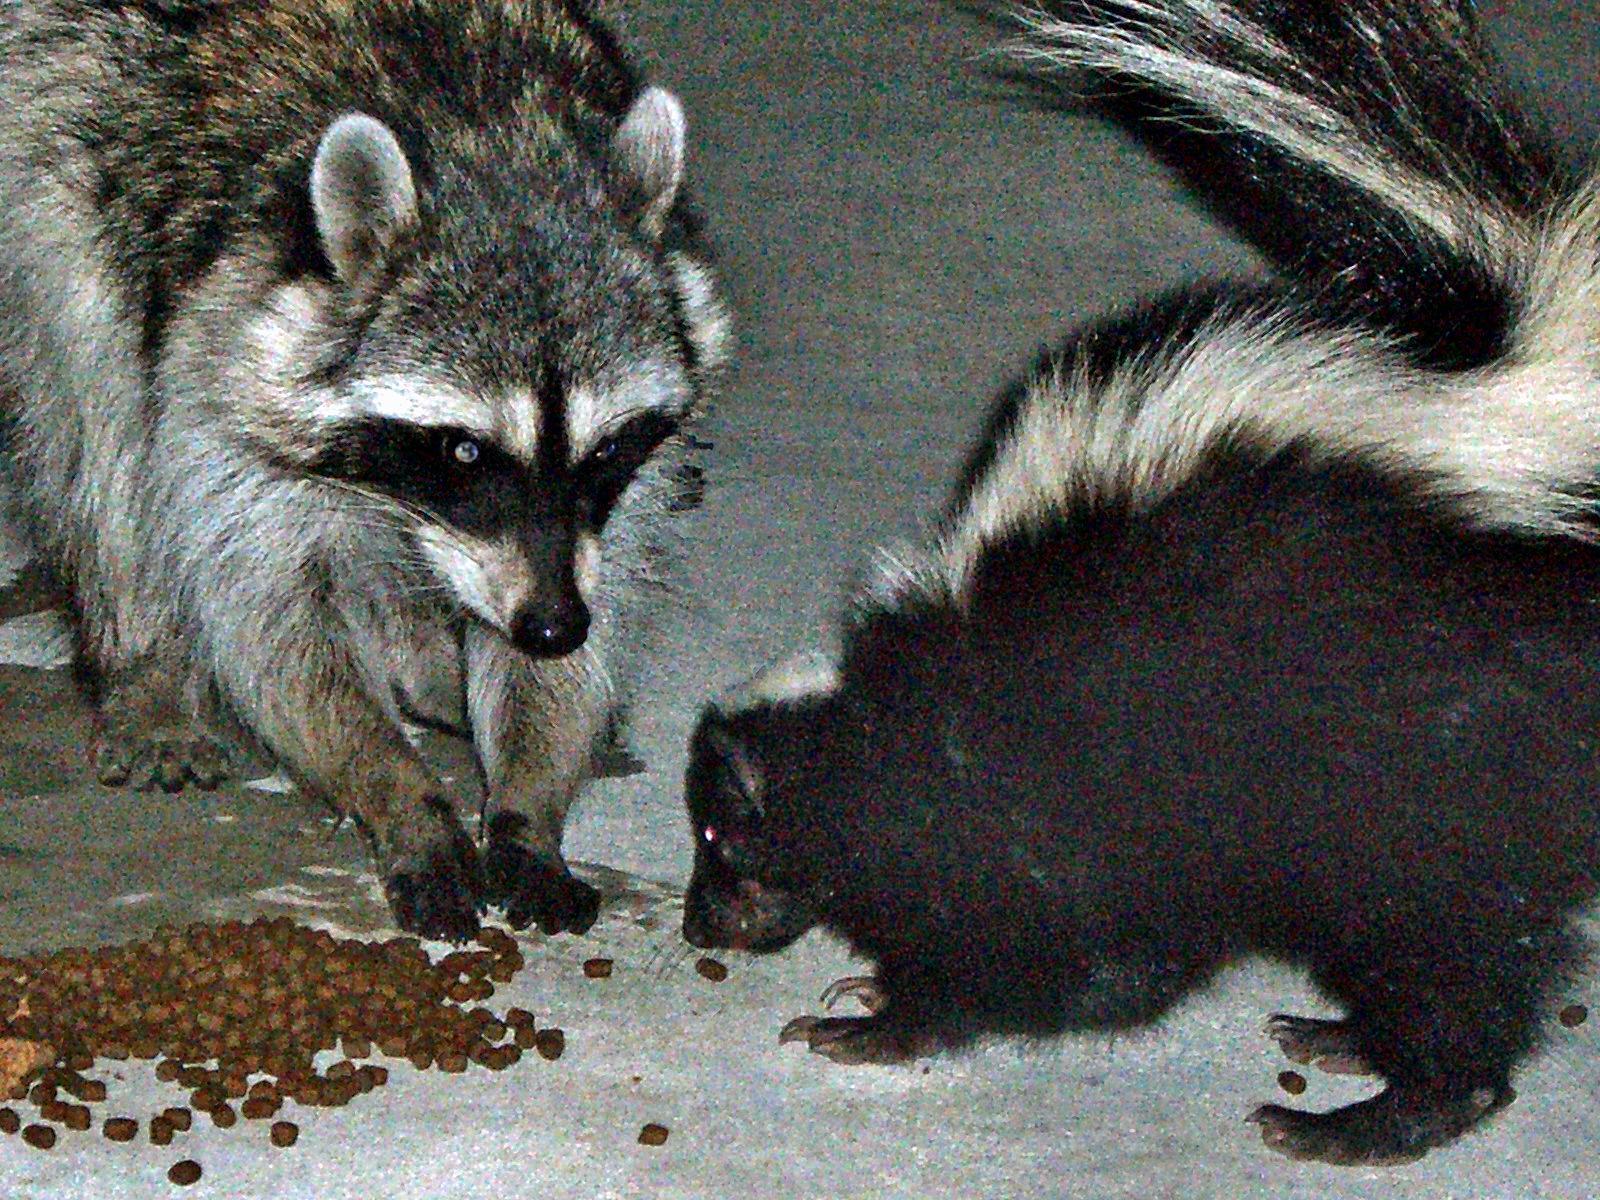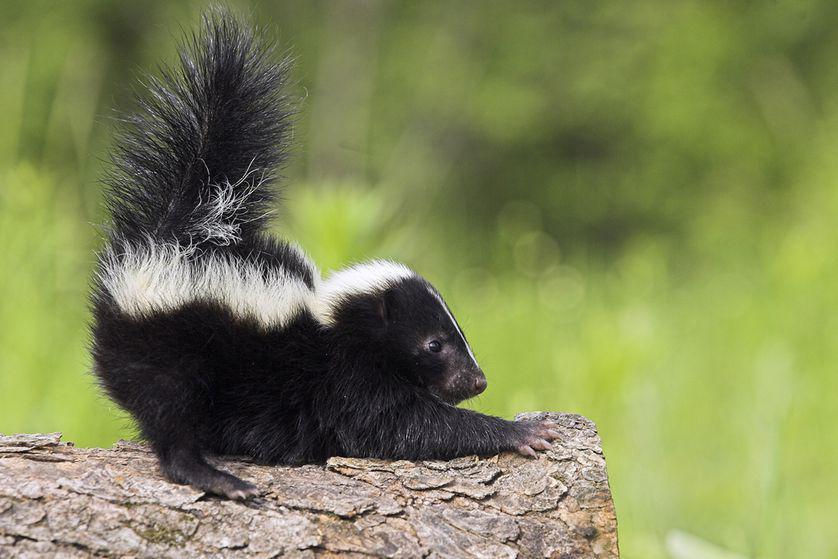The first image is the image on the left, the second image is the image on the right. For the images shown, is this caption "There is a skunk coming out from under a fallen tree log" true? Answer yes or no. No. 